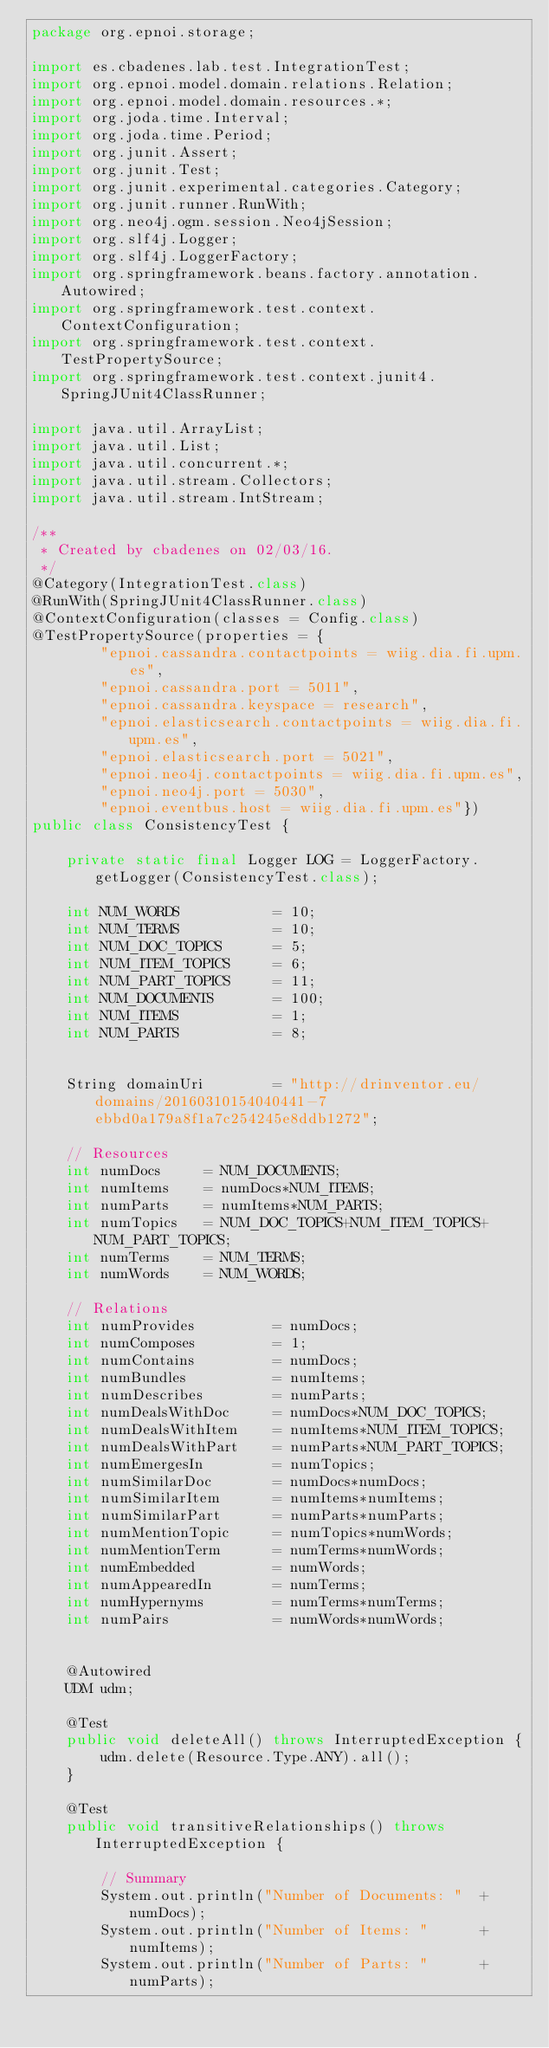<code> <loc_0><loc_0><loc_500><loc_500><_Java_>package org.epnoi.storage;

import es.cbadenes.lab.test.IntegrationTest;
import org.epnoi.model.domain.relations.Relation;
import org.epnoi.model.domain.resources.*;
import org.joda.time.Interval;
import org.joda.time.Period;
import org.junit.Assert;
import org.junit.Test;
import org.junit.experimental.categories.Category;
import org.junit.runner.RunWith;
import org.neo4j.ogm.session.Neo4jSession;
import org.slf4j.Logger;
import org.slf4j.LoggerFactory;
import org.springframework.beans.factory.annotation.Autowired;
import org.springframework.test.context.ContextConfiguration;
import org.springframework.test.context.TestPropertySource;
import org.springframework.test.context.junit4.SpringJUnit4ClassRunner;

import java.util.ArrayList;
import java.util.List;
import java.util.concurrent.*;
import java.util.stream.Collectors;
import java.util.stream.IntStream;

/**
 * Created by cbadenes on 02/03/16.
 */
@Category(IntegrationTest.class)
@RunWith(SpringJUnit4ClassRunner.class)
@ContextConfiguration(classes = Config.class)
@TestPropertySource(properties = {
        "epnoi.cassandra.contactpoints = wiig.dia.fi.upm.es",
        "epnoi.cassandra.port = 5011",
        "epnoi.cassandra.keyspace = research",
        "epnoi.elasticsearch.contactpoints = wiig.dia.fi.upm.es",
        "epnoi.elasticsearch.port = 5021",
        "epnoi.neo4j.contactpoints = wiig.dia.fi.upm.es",
        "epnoi.neo4j.port = 5030",
        "epnoi.eventbus.host = wiig.dia.fi.upm.es"})
public class ConsistencyTest {

    private static final Logger LOG = LoggerFactory.getLogger(ConsistencyTest.class);

    int NUM_WORDS           = 10;
    int NUM_TERMS           = 10;
    int NUM_DOC_TOPICS      = 5;
    int NUM_ITEM_TOPICS     = 6;
    int NUM_PART_TOPICS     = 11;
    int NUM_DOCUMENTS       = 100;
    int NUM_ITEMS           = 1;
    int NUM_PARTS           = 8;


    String domainUri        = "http://drinventor.eu/domains/20160310154040441-7ebbd0a179a8f1a7c254245e8ddb1272";

    // Resources
    int numDocs     = NUM_DOCUMENTS;
    int numItems    = numDocs*NUM_ITEMS;
    int numParts    = numItems*NUM_PARTS;
    int numTopics   = NUM_DOC_TOPICS+NUM_ITEM_TOPICS+NUM_PART_TOPICS;
    int numTerms    = NUM_TERMS;
    int numWords    = NUM_WORDS;

    // Relations
    int numProvides         = numDocs;
    int numComposes         = 1;
    int numContains         = numDocs;
    int numBundles          = numItems;
    int numDescribes        = numParts;
    int numDealsWithDoc     = numDocs*NUM_DOC_TOPICS;
    int numDealsWithItem    = numItems*NUM_ITEM_TOPICS;
    int numDealsWithPart    = numParts*NUM_PART_TOPICS;
    int numEmergesIn        = numTopics;
    int numSimilarDoc       = numDocs*numDocs;
    int numSimilarItem      = numItems*numItems;
    int numSimilarPart      = numParts*numParts;
    int numMentionTopic     = numTopics*numWords;
    int numMentionTerm      = numTerms*numWords;
    int numEmbedded         = numWords;
    int numAppearedIn       = numTerms;
    int numHypernyms        = numTerms*numTerms;
    int numPairs            = numWords*numWords;


    @Autowired
    UDM udm;

    @Test
    public void deleteAll() throws InterruptedException {
        udm.delete(Resource.Type.ANY).all();
    }

    @Test
    public void transitiveRelationships() throws InterruptedException {

        // Summary
        System.out.println("Number of Documents: "  + numDocs);
        System.out.println("Number of Items: "      + numItems);
        System.out.println("Number of Parts: "      + numParts);</code> 